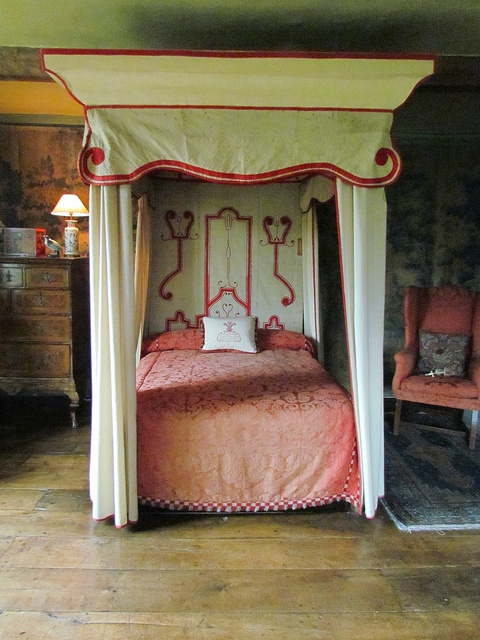Describe the objects in this image and their specific colors. I can see bed in olive, brown, lightpink, maroon, and tan tones and chair in olive, maroon, black, brown, and gray tones in this image. 